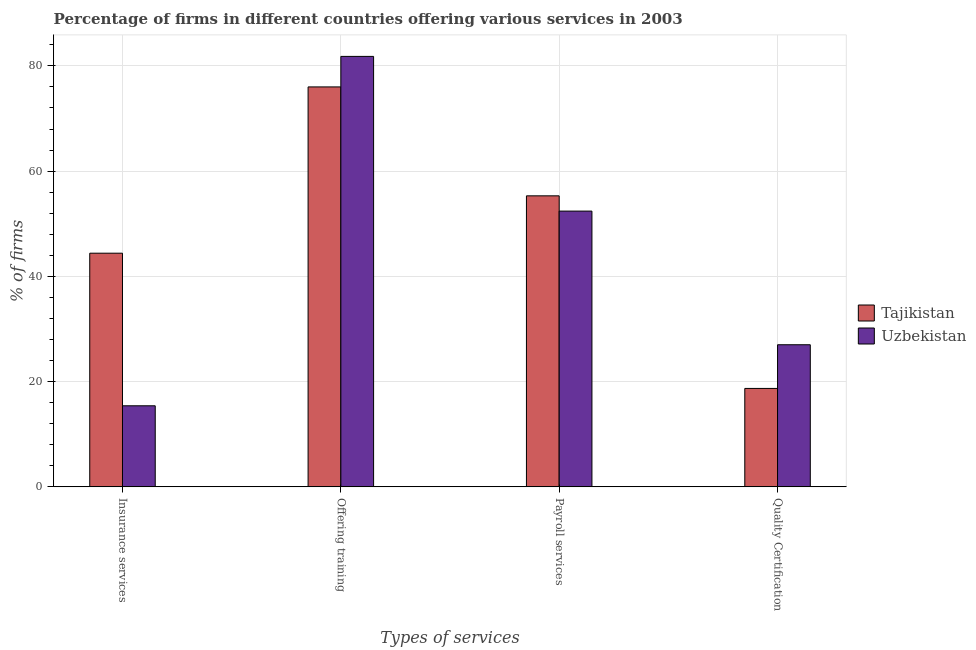How many bars are there on the 3rd tick from the left?
Give a very brief answer. 2. What is the label of the 2nd group of bars from the left?
Make the answer very short. Offering training. What is the percentage of firms offering training in Uzbekistan?
Keep it short and to the point. 81.8. Across all countries, what is the maximum percentage of firms offering training?
Keep it short and to the point. 81.8. In which country was the percentage of firms offering training maximum?
Your response must be concise. Uzbekistan. In which country was the percentage of firms offering insurance services minimum?
Your answer should be very brief. Uzbekistan. What is the total percentage of firms offering training in the graph?
Offer a very short reply. 157.8. What is the difference between the percentage of firms offering payroll services in Tajikistan and that in Uzbekistan?
Give a very brief answer. 2.9. What is the difference between the percentage of firms offering payroll services in Uzbekistan and the percentage of firms offering quality certification in Tajikistan?
Give a very brief answer. 33.7. What is the average percentage of firms offering quality certification per country?
Your answer should be compact. 22.85. What is the difference between the percentage of firms offering training and percentage of firms offering quality certification in Uzbekistan?
Provide a succinct answer. 54.8. What is the ratio of the percentage of firms offering quality certification in Tajikistan to that in Uzbekistan?
Offer a very short reply. 0.69. What is the difference between the highest and the second highest percentage of firms offering insurance services?
Offer a very short reply. 29. What is the difference between the highest and the lowest percentage of firms offering training?
Your response must be concise. 5.8. In how many countries, is the percentage of firms offering insurance services greater than the average percentage of firms offering insurance services taken over all countries?
Your answer should be very brief. 1. Is the sum of the percentage of firms offering quality certification in Uzbekistan and Tajikistan greater than the maximum percentage of firms offering training across all countries?
Give a very brief answer. No. Is it the case that in every country, the sum of the percentage of firms offering payroll services and percentage of firms offering insurance services is greater than the sum of percentage of firms offering quality certification and percentage of firms offering training?
Your answer should be very brief. Yes. What does the 2nd bar from the left in Offering training represents?
Give a very brief answer. Uzbekistan. What does the 2nd bar from the right in Payroll services represents?
Make the answer very short. Tajikistan. Is it the case that in every country, the sum of the percentage of firms offering insurance services and percentage of firms offering training is greater than the percentage of firms offering payroll services?
Offer a very short reply. Yes. How many bars are there?
Your response must be concise. 8. How many countries are there in the graph?
Provide a short and direct response. 2. Are the values on the major ticks of Y-axis written in scientific E-notation?
Offer a terse response. No. How are the legend labels stacked?
Your answer should be compact. Vertical. What is the title of the graph?
Make the answer very short. Percentage of firms in different countries offering various services in 2003. What is the label or title of the X-axis?
Your response must be concise. Types of services. What is the label or title of the Y-axis?
Your answer should be compact. % of firms. What is the % of firms of Tajikistan in Insurance services?
Your answer should be very brief. 44.4. What is the % of firms of Tajikistan in Offering training?
Offer a terse response. 76. What is the % of firms of Uzbekistan in Offering training?
Offer a terse response. 81.8. What is the % of firms in Tajikistan in Payroll services?
Give a very brief answer. 55.3. What is the % of firms in Uzbekistan in Payroll services?
Your response must be concise. 52.4. What is the % of firms of Tajikistan in Quality Certification?
Provide a succinct answer. 18.7. Across all Types of services, what is the maximum % of firms in Uzbekistan?
Your response must be concise. 81.8. What is the total % of firms of Tajikistan in the graph?
Your answer should be compact. 194.4. What is the total % of firms in Uzbekistan in the graph?
Ensure brevity in your answer.  176.6. What is the difference between the % of firms in Tajikistan in Insurance services and that in Offering training?
Offer a terse response. -31.6. What is the difference between the % of firms of Uzbekistan in Insurance services and that in Offering training?
Keep it short and to the point. -66.4. What is the difference between the % of firms in Tajikistan in Insurance services and that in Payroll services?
Ensure brevity in your answer.  -10.9. What is the difference between the % of firms of Uzbekistan in Insurance services and that in Payroll services?
Provide a succinct answer. -37. What is the difference between the % of firms in Tajikistan in Insurance services and that in Quality Certification?
Offer a terse response. 25.7. What is the difference between the % of firms of Uzbekistan in Insurance services and that in Quality Certification?
Provide a succinct answer. -11.6. What is the difference between the % of firms in Tajikistan in Offering training and that in Payroll services?
Make the answer very short. 20.7. What is the difference between the % of firms in Uzbekistan in Offering training and that in Payroll services?
Provide a succinct answer. 29.4. What is the difference between the % of firms of Tajikistan in Offering training and that in Quality Certification?
Your answer should be compact. 57.3. What is the difference between the % of firms in Uzbekistan in Offering training and that in Quality Certification?
Offer a terse response. 54.8. What is the difference between the % of firms in Tajikistan in Payroll services and that in Quality Certification?
Keep it short and to the point. 36.6. What is the difference between the % of firms in Uzbekistan in Payroll services and that in Quality Certification?
Ensure brevity in your answer.  25.4. What is the difference between the % of firms in Tajikistan in Insurance services and the % of firms in Uzbekistan in Offering training?
Keep it short and to the point. -37.4. What is the difference between the % of firms of Tajikistan in Insurance services and the % of firms of Uzbekistan in Payroll services?
Your answer should be compact. -8. What is the difference between the % of firms in Tajikistan in Insurance services and the % of firms in Uzbekistan in Quality Certification?
Ensure brevity in your answer.  17.4. What is the difference between the % of firms of Tajikistan in Offering training and the % of firms of Uzbekistan in Payroll services?
Your response must be concise. 23.6. What is the difference between the % of firms of Tajikistan in Payroll services and the % of firms of Uzbekistan in Quality Certification?
Offer a very short reply. 28.3. What is the average % of firms in Tajikistan per Types of services?
Offer a terse response. 48.6. What is the average % of firms in Uzbekistan per Types of services?
Provide a succinct answer. 44.15. What is the difference between the % of firms of Tajikistan and % of firms of Uzbekistan in Offering training?
Provide a succinct answer. -5.8. What is the difference between the % of firms in Tajikistan and % of firms in Uzbekistan in Payroll services?
Offer a very short reply. 2.9. What is the difference between the % of firms of Tajikistan and % of firms of Uzbekistan in Quality Certification?
Offer a very short reply. -8.3. What is the ratio of the % of firms of Tajikistan in Insurance services to that in Offering training?
Make the answer very short. 0.58. What is the ratio of the % of firms in Uzbekistan in Insurance services to that in Offering training?
Your answer should be compact. 0.19. What is the ratio of the % of firms in Tajikistan in Insurance services to that in Payroll services?
Offer a very short reply. 0.8. What is the ratio of the % of firms of Uzbekistan in Insurance services to that in Payroll services?
Provide a succinct answer. 0.29. What is the ratio of the % of firms in Tajikistan in Insurance services to that in Quality Certification?
Your answer should be very brief. 2.37. What is the ratio of the % of firms of Uzbekistan in Insurance services to that in Quality Certification?
Your response must be concise. 0.57. What is the ratio of the % of firms of Tajikistan in Offering training to that in Payroll services?
Offer a very short reply. 1.37. What is the ratio of the % of firms of Uzbekistan in Offering training to that in Payroll services?
Your response must be concise. 1.56. What is the ratio of the % of firms of Tajikistan in Offering training to that in Quality Certification?
Offer a very short reply. 4.06. What is the ratio of the % of firms in Uzbekistan in Offering training to that in Quality Certification?
Your answer should be compact. 3.03. What is the ratio of the % of firms in Tajikistan in Payroll services to that in Quality Certification?
Make the answer very short. 2.96. What is the ratio of the % of firms of Uzbekistan in Payroll services to that in Quality Certification?
Give a very brief answer. 1.94. What is the difference between the highest and the second highest % of firms of Tajikistan?
Provide a short and direct response. 20.7. What is the difference between the highest and the second highest % of firms of Uzbekistan?
Give a very brief answer. 29.4. What is the difference between the highest and the lowest % of firms of Tajikistan?
Provide a succinct answer. 57.3. What is the difference between the highest and the lowest % of firms of Uzbekistan?
Your answer should be compact. 66.4. 